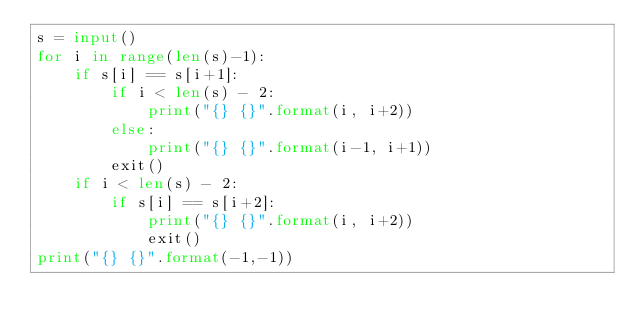<code> <loc_0><loc_0><loc_500><loc_500><_Python_>s = input()
for i in range(len(s)-1):
    if s[i] == s[i+1]:
        if i < len(s) - 2:
            print("{} {}".format(i, i+2))
        else:
            print("{} {}".format(i-1, i+1))
        exit()
    if i < len(s) - 2:
        if s[i] == s[i+2]:
            print("{} {}".format(i, i+2))
            exit()
print("{} {}".format(-1,-1))</code> 